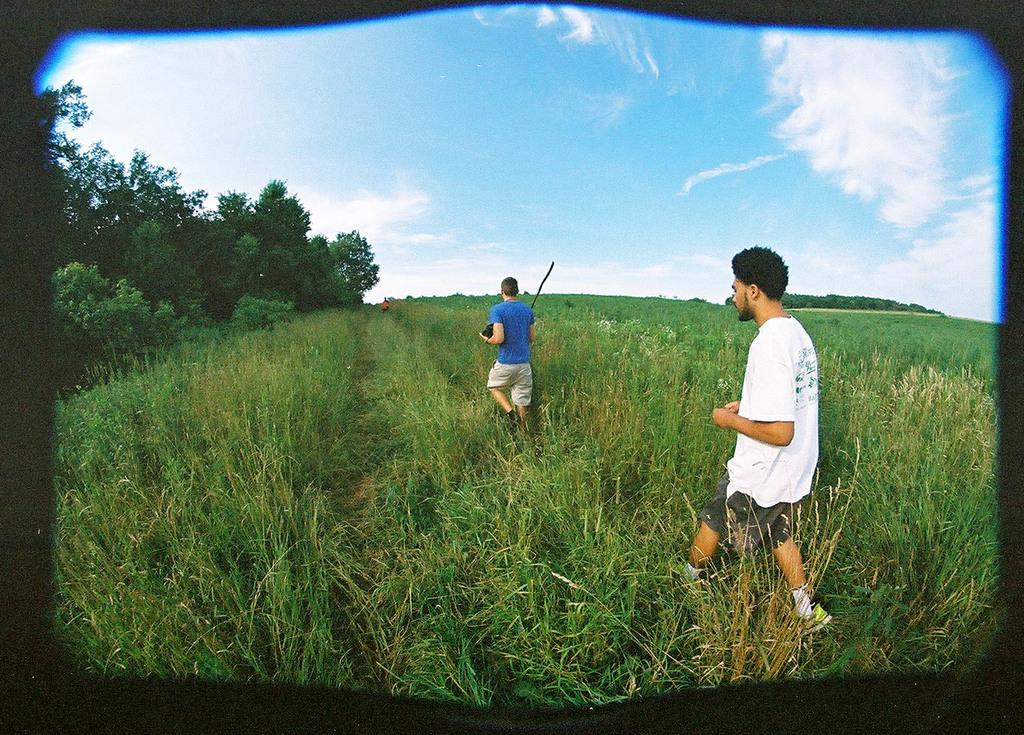What type of living organisms can be seen in the image? Plants and trees are visible in the image. What are the two people in the image doing? Two people are walking in the image. What else can be seen in the image besides plants and trees? There are objects in the image. What is visible in the background of the image? The sky is visible in the background of the image. What can be seen in the sky? Clouds are present in the sky. What type of cakes are the people eating while walking in the image? There is no indication of any cakes being eaten in the image; the two people are simply walking. Can you describe the stranger in the image? There is no stranger present in the image; only two people are visible. 